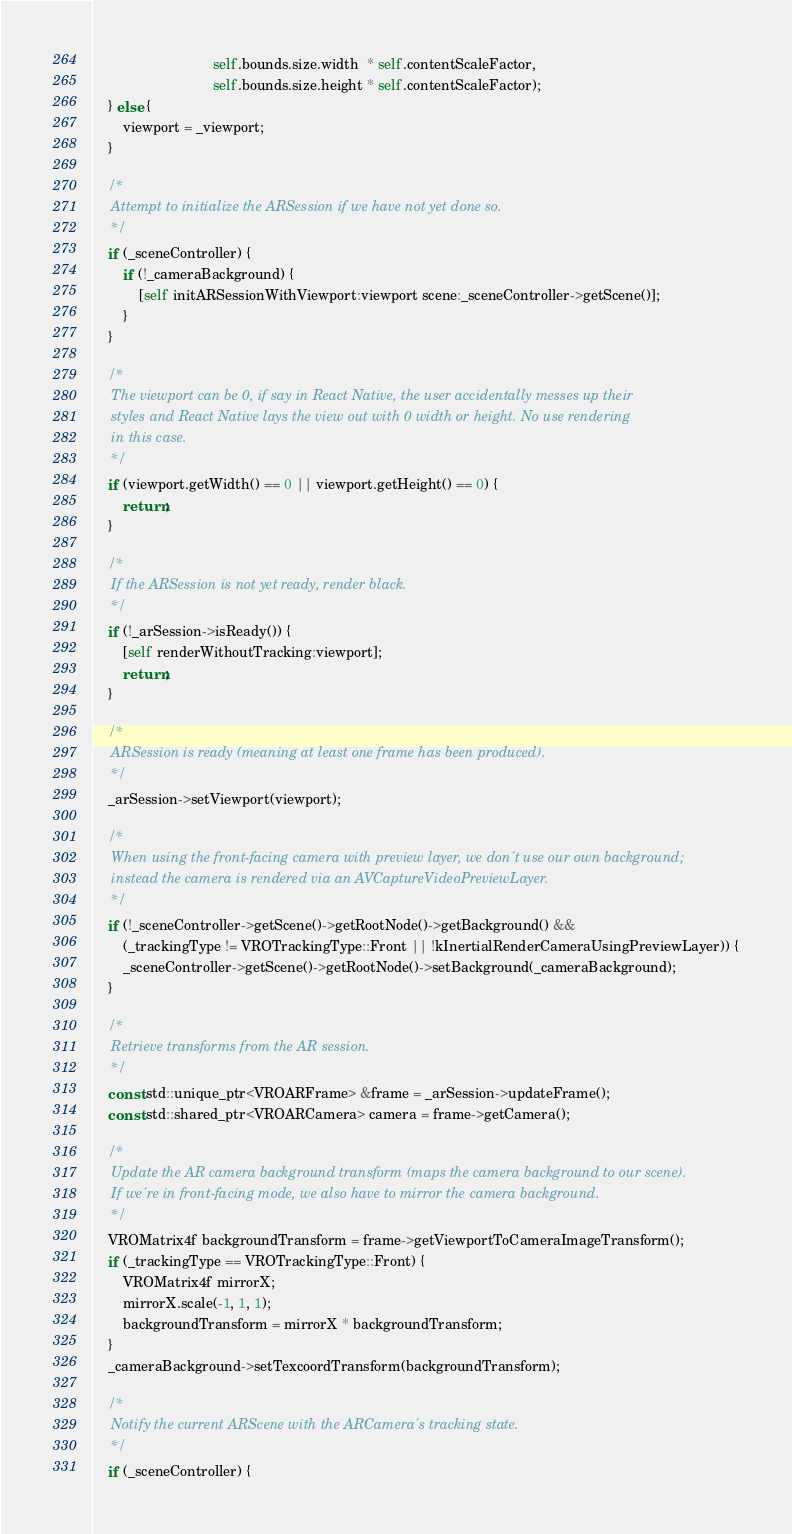Convert code to text. <code><loc_0><loc_0><loc_500><loc_500><_ObjectiveC_>                               self.bounds.size.width  * self.contentScaleFactor,
                               self.bounds.size.height * self.contentScaleFactor);
    } else {
        viewport = _viewport;
    }
    
    /*
     Attempt to initialize the ARSession if we have not yet done so.
     */
    if (_sceneController) {
        if (!_cameraBackground) {
            [self initARSessionWithViewport:viewport scene:_sceneController->getScene()];
        }
    }

    /*
     The viewport can be 0, if say in React Native, the user accidentally messes up their
     styles and React Native lays the view out with 0 width or height. No use rendering
     in this case.
     */
    if (viewport.getWidth() == 0 || viewport.getHeight() == 0) {
        return;
    }

    /*
     If the ARSession is not yet ready, render black.
     */
    if (!_arSession->isReady()) {
        [self renderWithoutTracking:viewport];
        return;
    }
    
    /*
     ARSession is ready (meaning at least one frame has been produced).
     */
    _arSession->setViewport(viewport);
    
    /*
     When using the front-facing camera with preview layer, we don't use our own background;
     instead the camera is rendered via an AVCaptureVideoPreviewLayer.
     */
    if (!_sceneController->getScene()->getRootNode()->getBackground() &&
        (_trackingType != VROTrackingType::Front || !kInertialRenderCameraUsingPreviewLayer)) {
        _sceneController->getScene()->getRootNode()->setBackground(_cameraBackground);
    }

    /*
     Retrieve transforms from the AR session.
     */
    const std::unique_ptr<VROARFrame> &frame = _arSession->updateFrame();
    const std::shared_ptr<VROARCamera> camera = frame->getCamera();

    /*
     Update the AR camera background transform (maps the camera background to our scene).
     If we're in front-facing mode, we also have to mirror the camera background.
     */
    VROMatrix4f backgroundTransform = frame->getViewportToCameraImageTransform();
    if (_trackingType == VROTrackingType::Front) {
        VROMatrix4f mirrorX;
        mirrorX.scale(-1, 1, 1);
        backgroundTransform = mirrorX * backgroundTransform;
    }
    _cameraBackground->setTexcoordTransform(backgroundTransform);

    /*
     Notify the current ARScene with the ARCamera's tracking state.
     */
    if (_sceneController) {</code> 